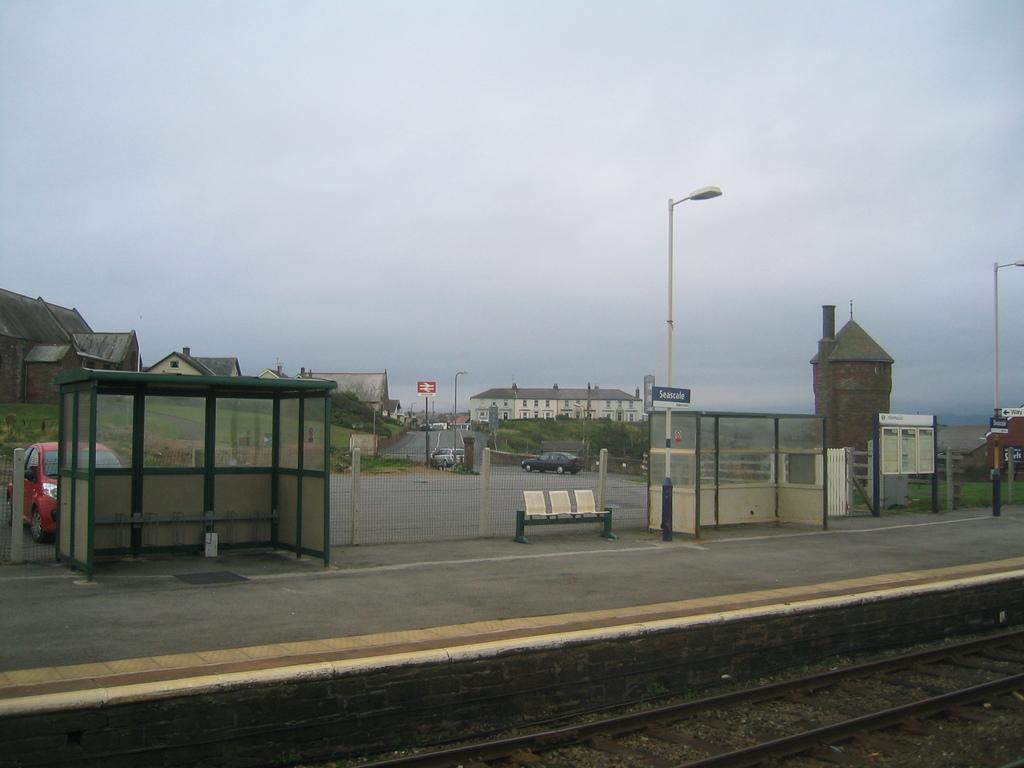Please provide a concise description of this image. In this image we can see a platform, railway tracks, benches, shed, poles, lights and mesh. In the background, we can see cars, buildings, boards, grassy land and poles. At the top of the image, we can see the sky. 